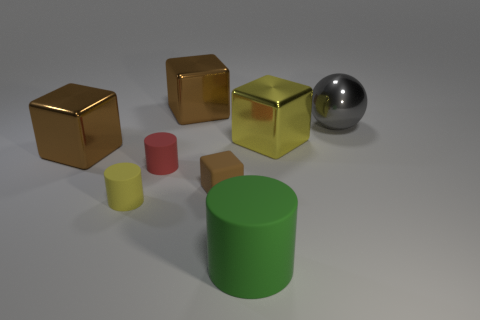How many brown cubes must be subtracted to get 1 brown cubes? 2 Subtract all cyan balls. How many brown cubes are left? 3 Add 2 metallic balls. How many objects exist? 10 Subtract all spheres. How many objects are left? 7 Subtract all large metallic blocks. Subtract all tiny brown objects. How many objects are left? 4 Add 1 small red cylinders. How many small red cylinders are left? 2 Add 1 big gray shiny objects. How many big gray shiny objects exist? 2 Subtract 0 green spheres. How many objects are left? 8 